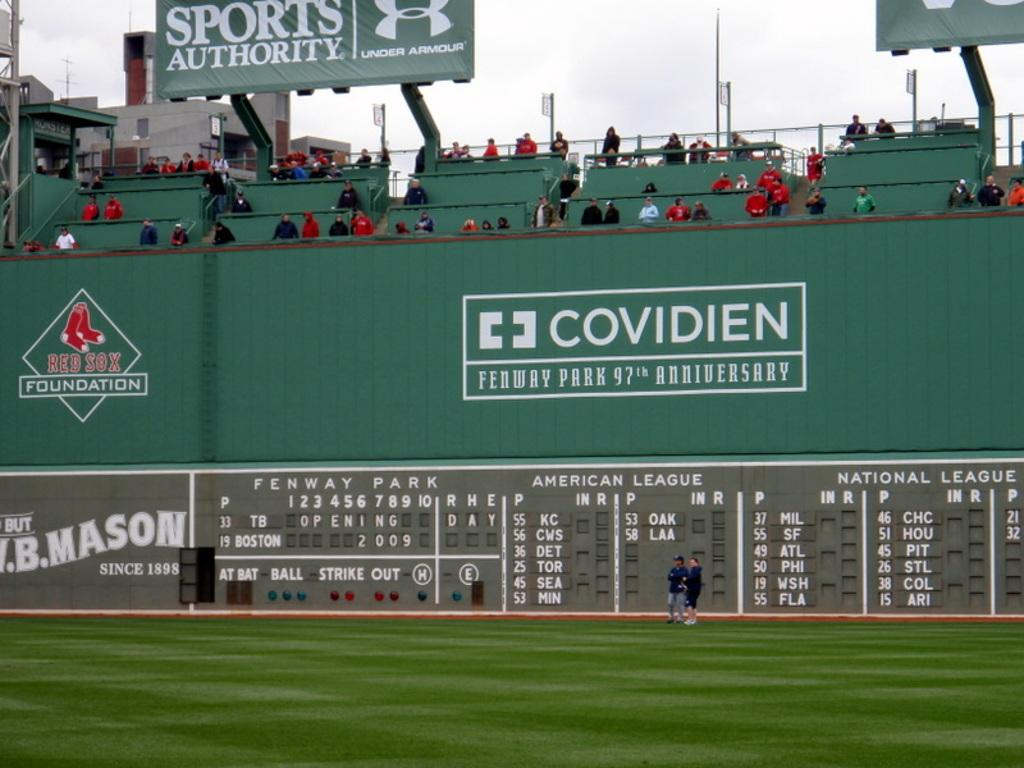Provide a one-sentence caption for the provided image. the big green monster at fenway ball park. 